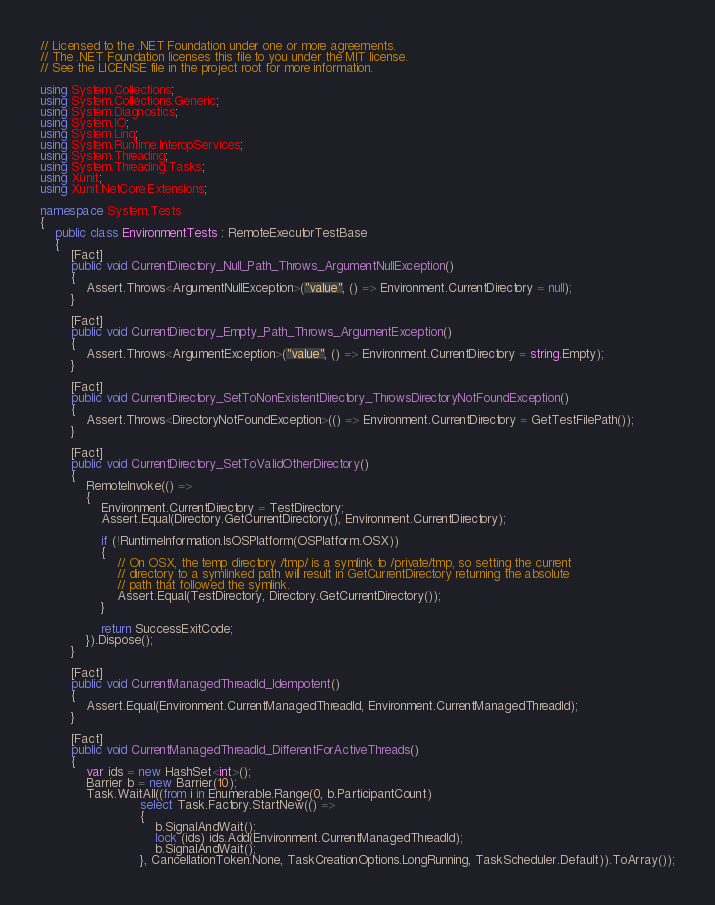<code> <loc_0><loc_0><loc_500><loc_500><_C#_>// Licensed to the .NET Foundation under one or more agreements.
// The .NET Foundation licenses this file to you under the MIT license.
// See the LICENSE file in the project root for more information.

using System.Collections;
using System.Collections.Generic;
using System.Diagnostics;
using System.IO;
using System.Linq;
using System.Runtime.InteropServices;
using System.Threading;
using System.Threading.Tasks;
using Xunit;
using Xunit.NetCore.Extensions;

namespace System.Tests
{
    public class EnvironmentTests : RemoteExecutorTestBase
    {
        [Fact]
        public void CurrentDirectory_Null_Path_Throws_ArgumentNullException()
        {
            Assert.Throws<ArgumentNullException>("value", () => Environment.CurrentDirectory = null);
        }

        [Fact]
        public void CurrentDirectory_Empty_Path_Throws_ArgumentException()
        {
            Assert.Throws<ArgumentException>("value", () => Environment.CurrentDirectory = string.Empty);
        }

        [Fact]
        public void CurrentDirectory_SetToNonExistentDirectory_ThrowsDirectoryNotFoundException()
        {
            Assert.Throws<DirectoryNotFoundException>(() => Environment.CurrentDirectory = GetTestFilePath());
        }

        [Fact]
        public void CurrentDirectory_SetToValidOtherDirectory()
        {
            RemoteInvoke(() =>
            {
                Environment.CurrentDirectory = TestDirectory;
                Assert.Equal(Directory.GetCurrentDirectory(), Environment.CurrentDirectory);

                if (!RuntimeInformation.IsOSPlatform(OSPlatform.OSX))
                {
                    // On OSX, the temp directory /tmp/ is a symlink to /private/tmp, so setting the current
                    // directory to a symlinked path will result in GetCurrentDirectory returning the absolute
                    // path that followed the symlink.
                    Assert.Equal(TestDirectory, Directory.GetCurrentDirectory());
                }

                return SuccessExitCode;
            }).Dispose();
        }

        [Fact]
        public void CurrentManagedThreadId_Idempotent()
        {
            Assert.Equal(Environment.CurrentManagedThreadId, Environment.CurrentManagedThreadId);
        }

        [Fact]
        public void CurrentManagedThreadId_DifferentForActiveThreads()
        {
            var ids = new HashSet<int>();
            Barrier b = new Barrier(10);
            Task.WaitAll((from i in Enumerable.Range(0, b.ParticipantCount)
                          select Task.Factory.StartNew(() =>
                          {
                              b.SignalAndWait();
                              lock (ids) ids.Add(Environment.CurrentManagedThreadId);
                              b.SignalAndWait();
                          }, CancellationToken.None, TaskCreationOptions.LongRunning, TaskScheduler.Default)).ToArray());</code> 